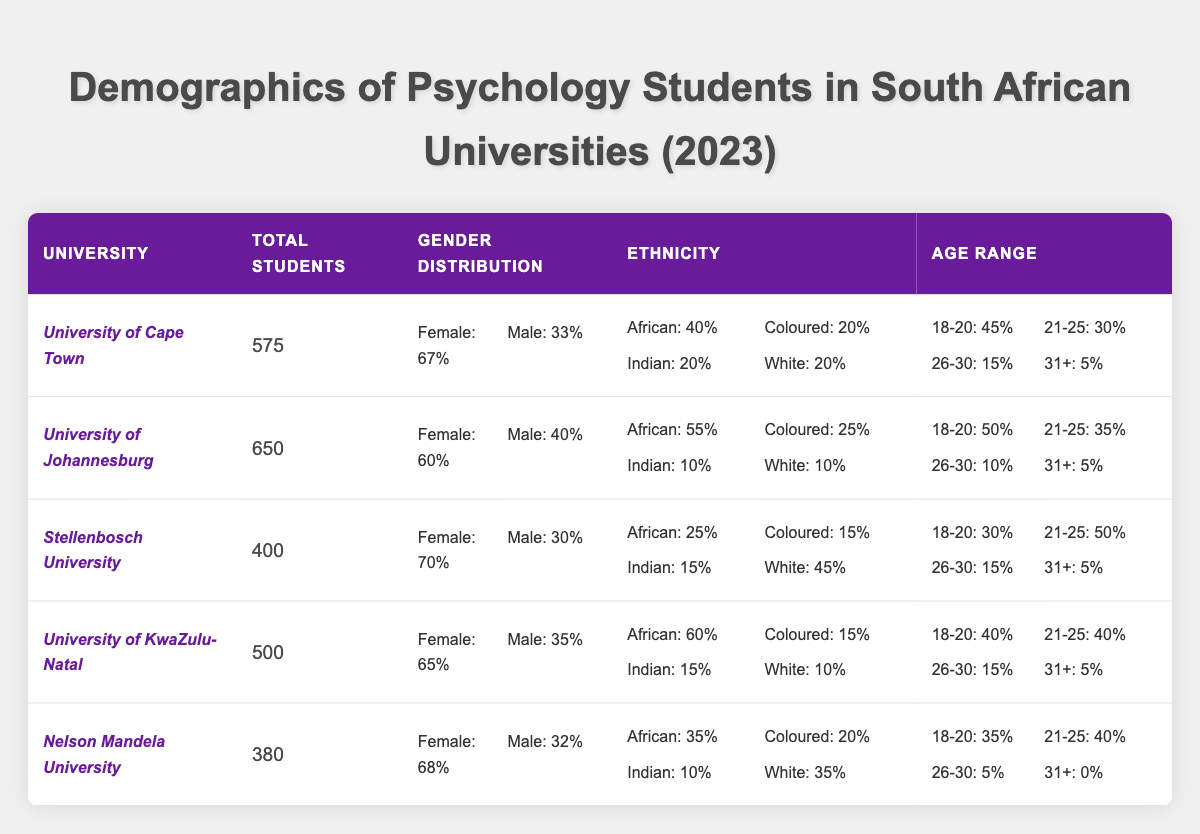What is the total number of psychology students at the University of Cape Town? The table shows that the total number of psychology students at the University of Cape Town is listed directly as 575.
Answer: 575 What percentage of psychology students at the University of Johannesburg are female? The table indicates that 60% of psychology students at the University of Johannesburg are female.
Answer: 60% How many total students are there across all five universities listed? To find the total, sum the values: 575 + 650 + 400 + 500 + 380 = 2505.
Answer: 2505 Which university has the highest percentage of male students? The table shows that the University of Johannesburg has the highest percentage of male students at 40%.
Answer: University of Johannesburg Which university has the lowest representation of African students? The data shows that Stellenbosch University has the lowest percentage of African students at 25%.
Answer: Stellenbosch University Is the percentage of female students at the University of KwaZulu-Natal higher than at Nelson Mandela University? The University of KwaZulu-Natal has 65% female students, while Nelson Mandela University has 68%. Since 68% is higher than 65%, the statement is false.
Answer: No What is the average percentage of male students across all the universities? Add the male percentages (33 + 40 + 30 + 35 + 32 = 170). Divide by the number of universities (5) to get the average: 170/5 = 34%.
Answer: 34% Which university has the highest proportion of students aged 21-25? Looking at the age range distribution, Stellenbosch University has the highest proportion of students aged 21-25 at 50%.
Answer: Stellenbosch University If we consider those aged 18-20 at Nelson Mandela University, how does this compare to the percentage of students aged 18-20 at the University of Cape Town? Nelson Mandela University has 35% and the University of Cape Town has 45%. Since 45% is higher than 35%, University of Cape Town has a greater percentage of students aged 18-20.
Answer: University of Cape Town What is the combined percentage of Coloured and Indian students at the University of Johannesburg? The table shows 25% Coloured and 10% Indian. Their combined percentage is 25% + 10% = 35%.
Answer: 35% 